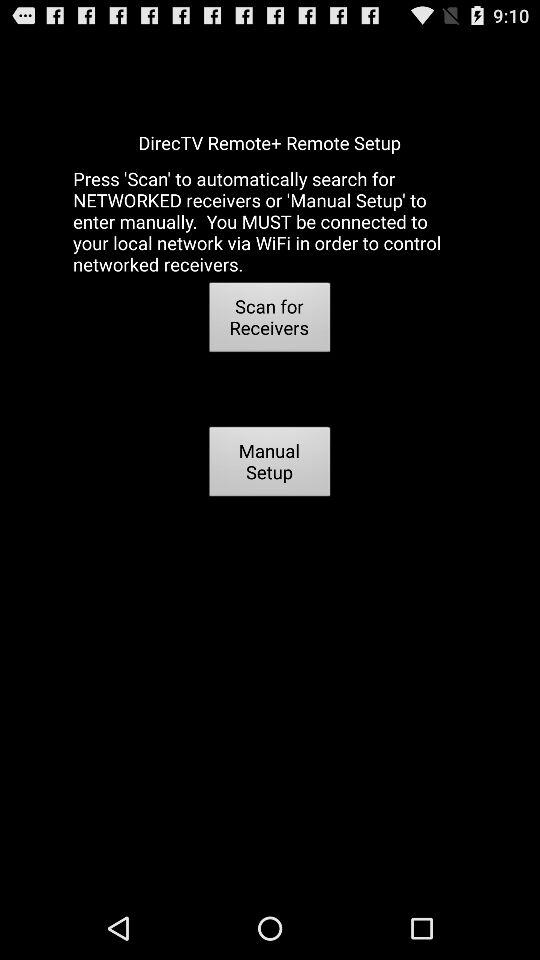What is the name of the application? The name of the application is "DirecTV Remote+". 